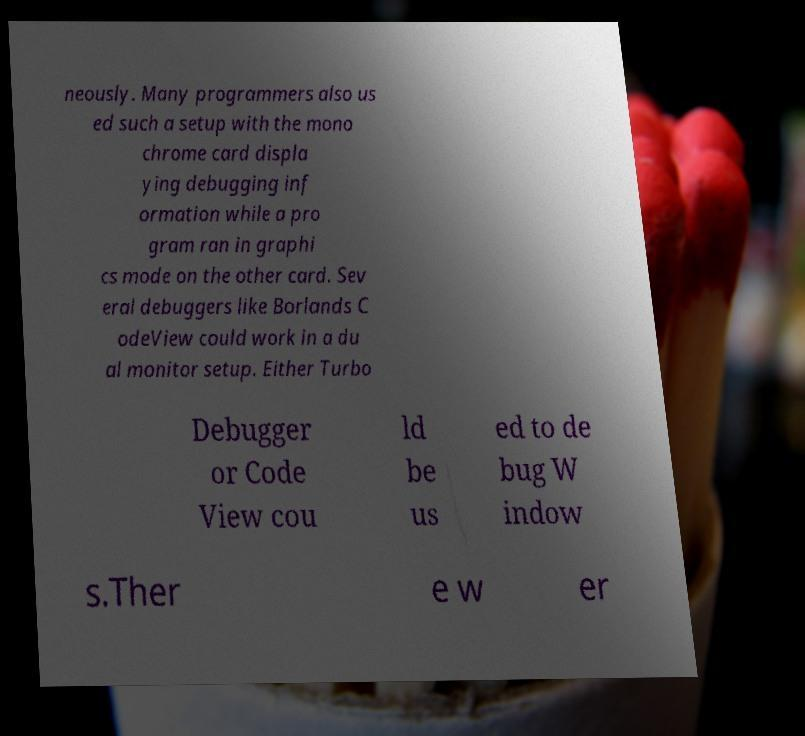I need the written content from this picture converted into text. Can you do that? neously. Many programmers also us ed such a setup with the mono chrome card displa ying debugging inf ormation while a pro gram ran in graphi cs mode on the other card. Sev eral debuggers like Borlands C odeView could work in a du al monitor setup. Either Turbo Debugger or Code View cou ld be us ed to de bug W indow s.Ther e w er 